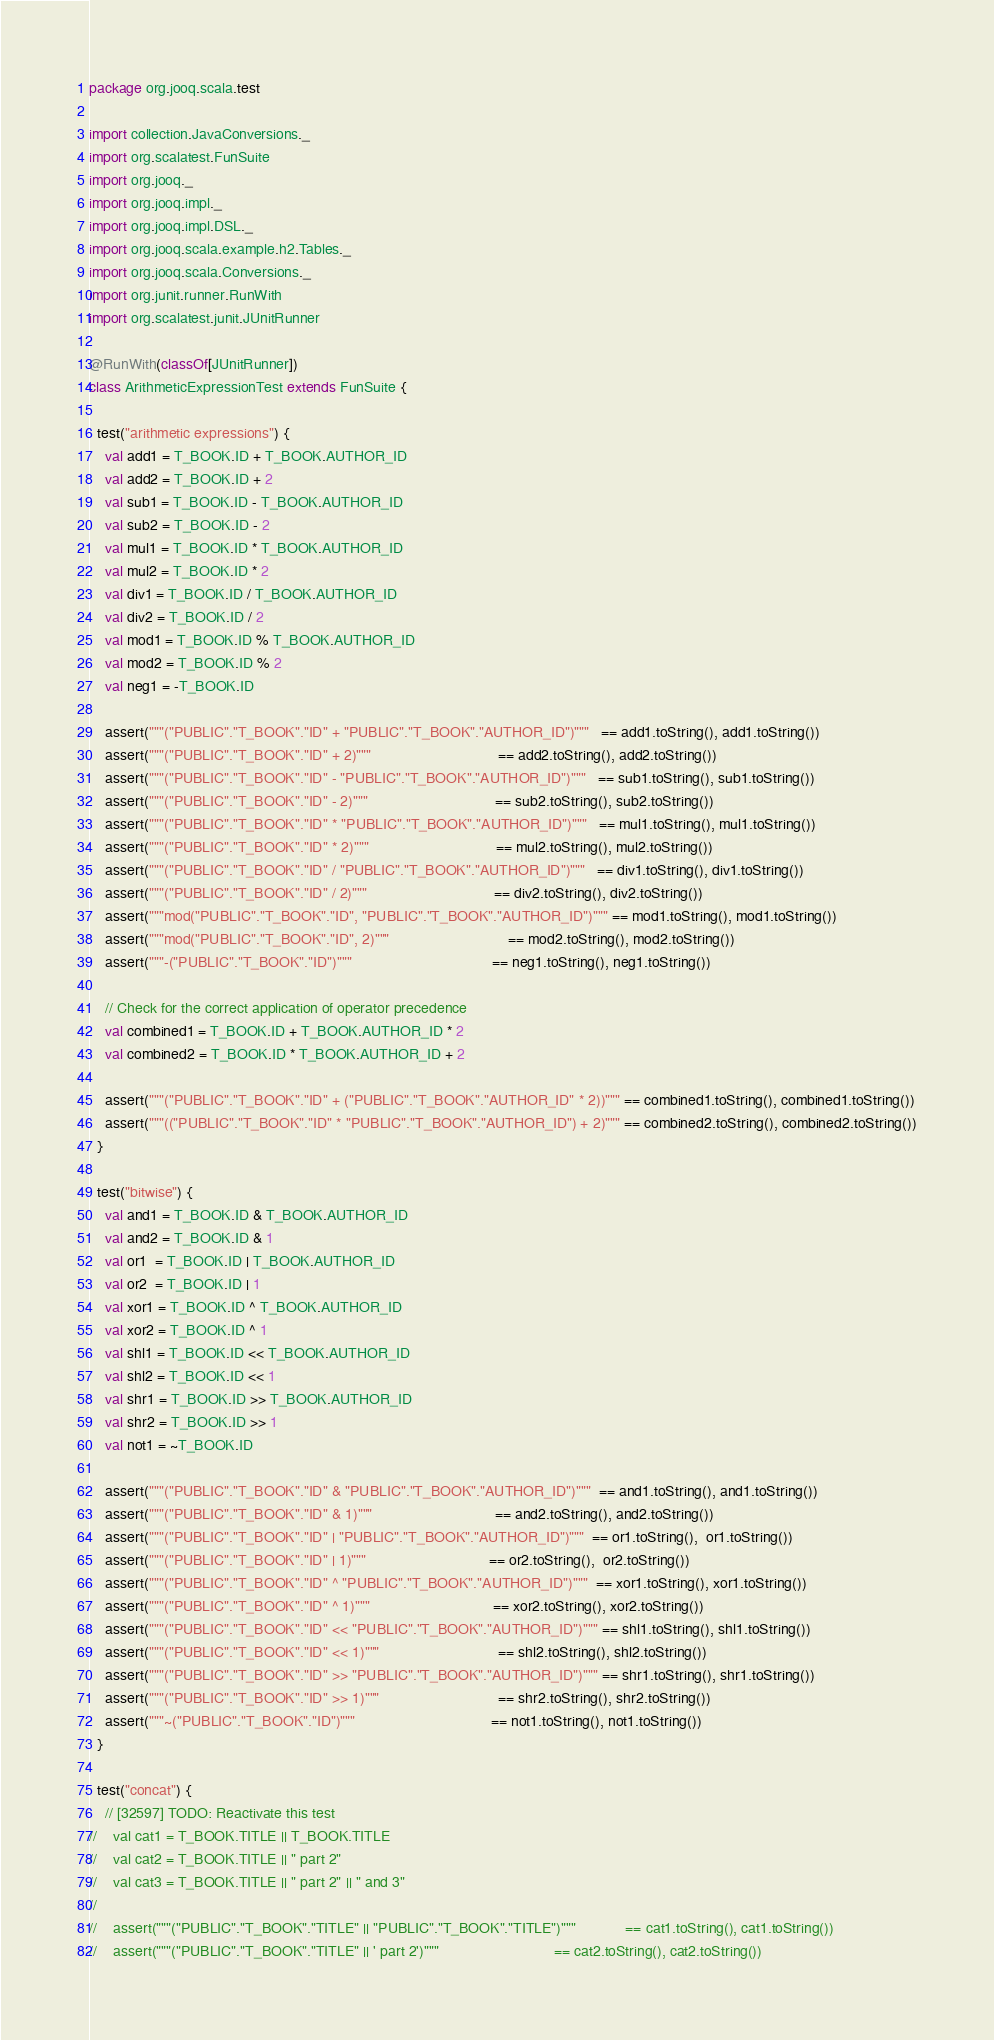<code> <loc_0><loc_0><loc_500><loc_500><_Scala_>package org.jooq.scala.test

import collection.JavaConversions._
import org.scalatest.FunSuite
import org.jooq._
import org.jooq.impl._
import org.jooq.impl.DSL._
import org.jooq.scala.example.h2.Tables._
import org.jooq.scala.Conversions._
import org.junit.runner.RunWith
import org.scalatest.junit.JUnitRunner

@RunWith(classOf[JUnitRunner])
class ArithmeticExpressionTest extends FunSuite {

  test("arithmetic expressions") {
    val add1 = T_BOOK.ID + T_BOOK.AUTHOR_ID
    val add2 = T_BOOK.ID + 2
    val sub1 = T_BOOK.ID - T_BOOK.AUTHOR_ID
    val sub2 = T_BOOK.ID - 2
    val mul1 = T_BOOK.ID * T_BOOK.AUTHOR_ID
    val mul2 = T_BOOK.ID * 2
    val div1 = T_BOOK.ID / T_BOOK.AUTHOR_ID
    val div2 = T_BOOK.ID / 2
    val mod1 = T_BOOK.ID % T_BOOK.AUTHOR_ID
    val mod2 = T_BOOK.ID % 2
    val neg1 = -T_BOOK.ID

    assert("""("PUBLIC"."T_BOOK"."ID" + "PUBLIC"."T_BOOK"."AUTHOR_ID")"""   == add1.toString(), add1.toString())
    assert("""("PUBLIC"."T_BOOK"."ID" + 2)"""                               == add2.toString(), add2.toString())
    assert("""("PUBLIC"."T_BOOK"."ID" - "PUBLIC"."T_BOOK"."AUTHOR_ID")"""   == sub1.toString(), sub1.toString())
    assert("""("PUBLIC"."T_BOOK"."ID" - 2)"""                               == sub2.toString(), sub2.toString())
    assert("""("PUBLIC"."T_BOOK"."ID" * "PUBLIC"."T_BOOK"."AUTHOR_ID")"""   == mul1.toString(), mul1.toString())
    assert("""("PUBLIC"."T_BOOK"."ID" * 2)"""                               == mul2.toString(), mul2.toString())
    assert("""("PUBLIC"."T_BOOK"."ID" / "PUBLIC"."T_BOOK"."AUTHOR_ID")"""   == div1.toString(), div1.toString())
    assert("""("PUBLIC"."T_BOOK"."ID" / 2)"""                               == div2.toString(), div2.toString())
    assert("""mod("PUBLIC"."T_BOOK"."ID", "PUBLIC"."T_BOOK"."AUTHOR_ID")""" == mod1.toString(), mod1.toString())
    assert("""mod("PUBLIC"."T_BOOK"."ID", 2)"""                             == mod2.toString(), mod2.toString())
    assert("""-("PUBLIC"."T_BOOK"."ID")"""                                  == neg1.toString(), neg1.toString())

    // Check for the correct application of operator precedence
    val combined1 = T_BOOK.ID + T_BOOK.AUTHOR_ID * 2
    val combined2 = T_BOOK.ID * T_BOOK.AUTHOR_ID + 2

    assert("""("PUBLIC"."T_BOOK"."ID" + ("PUBLIC"."T_BOOK"."AUTHOR_ID" * 2))""" == combined1.toString(), combined1.toString())
    assert("""(("PUBLIC"."T_BOOK"."ID" * "PUBLIC"."T_BOOK"."AUTHOR_ID") + 2)""" == combined2.toString(), combined2.toString())
  }

  test("bitwise") {
    val and1 = T_BOOK.ID & T_BOOK.AUTHOR_ID
    val and2 = T_BOOK.ID & 1
    val or1  = T_BOOK.ID | T_BOOK.AUTHOR_ID
    val or2  = T_BOOK.ID | 1
    val xor1 = T_BOOK.ID ^ T_BOOK.AUTHOR_ID
    val xor2 = T_BOOK.ID ^ 1
    val shl1 = T_BOOK.ID << T_BOOK.AUTHOR_ID
    val shl2 = T_BOOK.ID << 1
    val shr1 = T_BOOK.ID >> T_BOOK.AUTHOR_ID
    val shr2 = T_BOOK.ID >> 1
    val not1 = ~T_BOOK.ID

    assert("""("PUBLIC"."T_BOOK"."ID" & "PUBLIC"."T_BOOK"."AUTHOR_ID")"""  == and1.toString(), and1.toString())
    assert("""("PUBLIC"."T_BOOK"."ID" & 1)"""                              == and2.toString(), and2.toString())
    assert("""("PUBLIC"."T_BOOK"."ID" | "PUBLIC"."T_BOOK"."AUTHOR_ID")"""  == or1.toString(),  or1.toString())
    assert("""("PUBLIC"."T_BOOK"."ID" | 1)"""                              == or2.toString(),  or2.toString())
    assert("""("PUBLIC"."T_BOOK"."ID" ^ "PUBLIC"."T_BOOK"."AUTHOR_ID")"""  == xor1.toString(), xor1.toString())
    assert("""("PUBLIC"."T_BOOK"."ID" ^ 1)"""                              == xor2.toString(), xor2.toString())
    assert("""("PUBLIC"."T_BOOK"."ID" << "PUBLIC"."T_BOOK"."AUTHOR_ID")""" == shl1.toString(), shl1.toString())
    assert("""("PUBLIC"."T_BOOK"."ID" << 1)"""                             == shl2.toString(), shl2.toString())
    assert("""("PUBLIC"."T_BOOK"."ID" >> "PUBLIC"."T_BOOK"."AUTHOR_ID")""" == shr1.toString(), shr1.toString())
    assert("""("PUBLIC"."T_BOOK"."ID" >> 1)"""                             == shr2.toString(), shr2.toString())
    assert("""~("PUBLIC"."T_BOOK"."ID")"""                                 == not1.toString(), not1.toString())
  }

  test("concat") {
    // [32597] TODO: Reactivate this test
//    val cat1 = T_BOOK.TITLE || T_BOOK.TITLE
//    val cat2 = T_BOOK.TITLE || " part 2"
//    val cat3 = T_BOOK.TITLE || " part 2" || " and 3"
//
//    assert("""("PUBLIC"."T_BOOK"."TITLE" || "PUBLIC"."T_BOOK"."TITLE")"""            == cat1.toString(), cat1.toString())
//    assert("""("PUBLIC"."T_BOOK"."TITLE" || ' part 2')"""                            == cat2.toString(), cat2.toString())</code> 